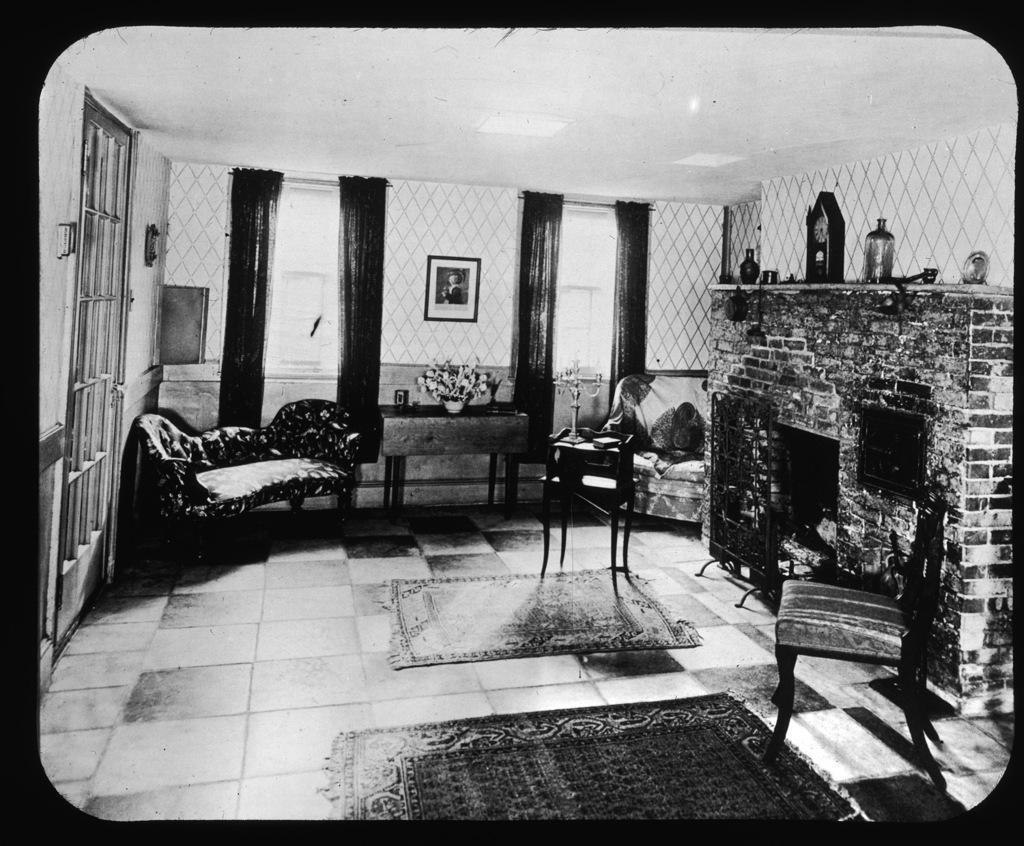Describe this image in one or two sentences. Here we can see me photograph and on the right side we can see a fire stock and there are couple of chairs present and there is a sofa present and here we can see windows present on wall with curtains to it and there is a portrait present on the wall and there are carpets present on floor 